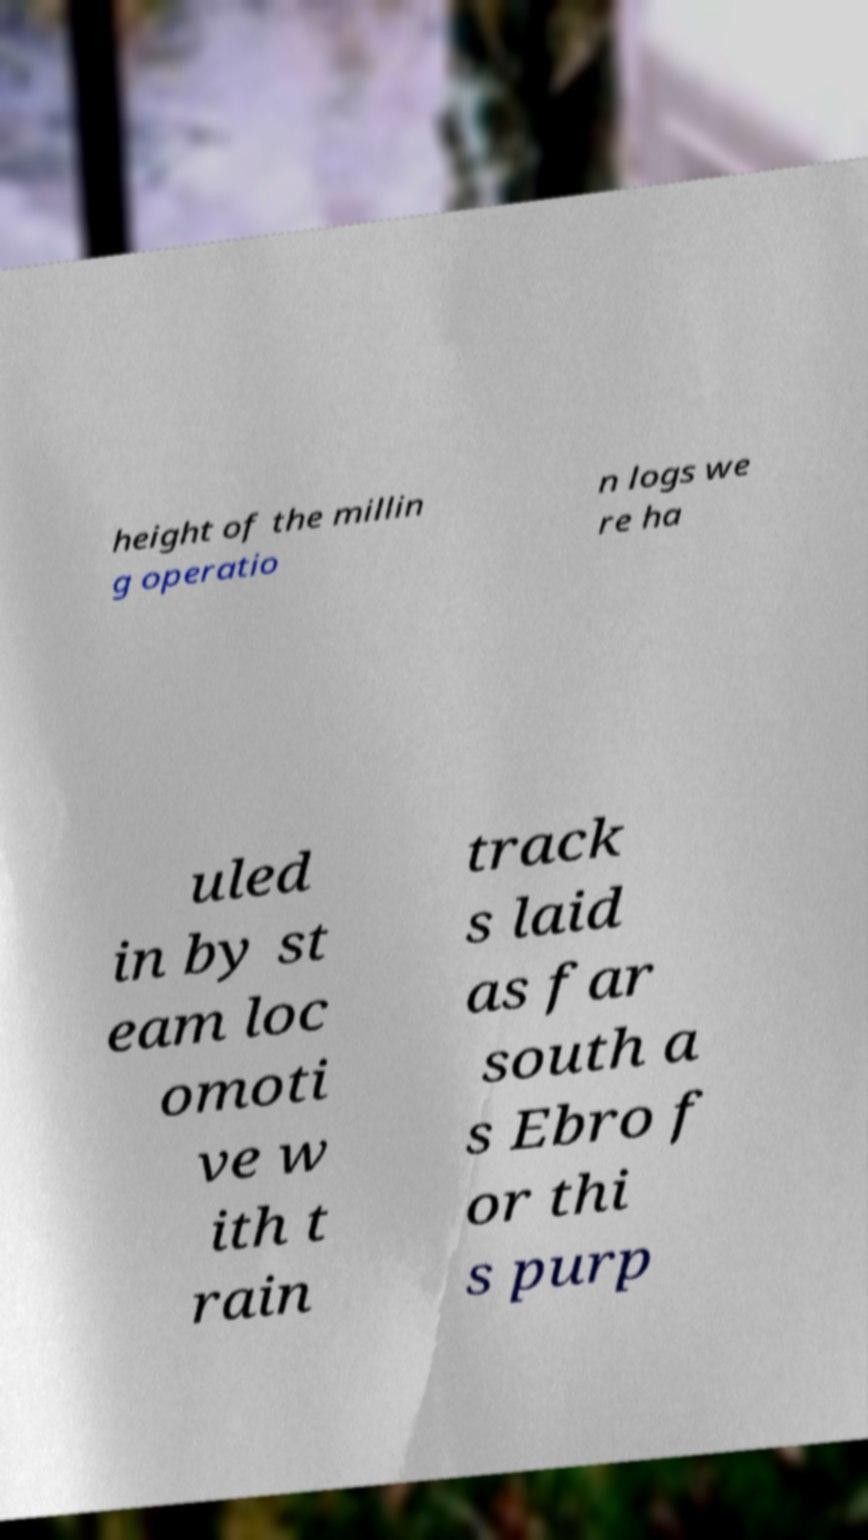What messages or text are displayed in this image? I need them in a readable, typed format. height of the millin g operatio n logs we re ha uled in by st eam loc omoti ve w ith t rain track s laid as far south a s Ebro f or thi s purp 